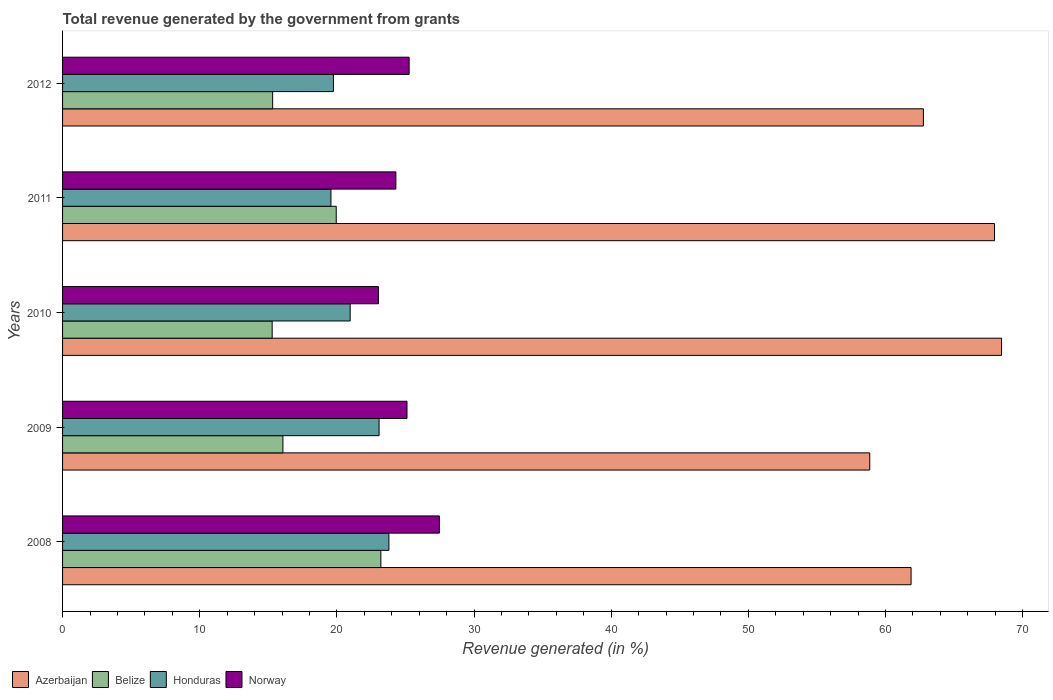What is the label of the 5th group of bars from the top?
Give a very brief answer. 2008. In how many cases, is the number of bars for a given year not equal to the number of legend labels?
Offer a very short reply. 0. What is the total revenue generated in Norway in 2011?
Give a very brief answer. 24.3. Across all years, what is the maximum total revenue generated in Honduras?
Make the answer very short. 23.79. Across all years, what is the minimum total revenue generated in Belize?
Your answer should be very brief. 15.28. In which year was the total revenue generated in Azerbaijan maximum?
Your answer should be compact. 2010. In which year was the total revenue generated in Norway minimum?
Provide a succinct answer. 2010. What is the total total revenue generated in Honduras in the graph?
Provide a succinct answer. 107.16. What is the difference between the total revenue generated in Norway in 2008 and that in 2012?
Offer a very short reply. 2.2. What is the difference between the total revenue generated in Honduras in 2011 and the total revenue generated in Belize in 2008?
Offer a terse response. -3.64. What is the average total revenue generated in Azerbaijan per year?
Your answer should be compact. 63.98. In the year 2012, what is the difference between the total revenue generated in Azerbaijan and total revenue generated in Honduras?
Provide a short and direct response. 43.01. In how many years, is the total revenue generated in Norway greater than 6 %?
Your response must be concise. 5. What is the ratio of the total revenue generated in Azerbaijan in 2008 to that in 2009?
Provide a short and direct response. 1.05. Is the total revenue generated in Azerbaijan in 2008 less than that in 2012?
Provide a short and direct response. Yes. Is the difference between the total revenue generated in Azerbaijan in 2009 and 2012 greater than the difference between the total revenue generated in Honduras in 2009 and 2012?
Your answer should be compact. No. What is the difference between the highest and the second highest total revenue generated in Belize?
Give a very brief answer. 3.25. What is the difference between the highest and the lowest total revenue generated in Belize?
Provide a succinct answer. 7.93. Is it the case that in every year, the sum of the total revenue generated in Belize and total revenue generated in Honduras is greater than the sum of total revenue generated in Norway and total revenue generated in Azerbaijan?
Your answer should be compact. No. What does the 1st bar from the bottom in 2011 represents?
Offer a terse response. Azerbaijan. Is it the case that in every year, the sum of the total revenue generated in Norway and total revenue generated in Belize is greater than the total revenue generated in Honduras?
Offer a terse response. Yes. How many years are there in the graph?
Provide a succinct answer. 5. Does the graph contain any zero values?
Your answer should be very brief. No. Does the graph contain grids?
Your response must be concise. No. Where does the legend appear in the graph?
Provide a succinct answer. Bottom left. How many legend labels are there?
Give a very brief answer. 4. How are the legend labels stacked?
Keep it short and to the point. Horizontal. What is the title of the graph?
Offer a terse response. Total revenue generated by the government from grants. Does "Isle of Man" appear as one of the legend labels in the graph?
Make the answer very short. No. What is the label or title of the X-axis?
Offer a terse response. Revenue generated (in %). What is the Revenue generated (in %) in Azerbaijan in 2008?
Your answer should be compact. 61.87. What is the Revenue generated (in %) of Belize in 2008?
Provide a short and direct response. 23.21. What is the Revenue generated (in %) in Honduras in 2008?
Your answer should be very brief. 23.79. What is the Revenue generated (in %) in Norway in 2008?
Your response must be concise. 27.47. What is the Revenue generated (in %) of Azerbaijan in 2009?
Your answer should be compact. 58.85. What is the Revenue generated (in %) of Belize in 2009?
Make the answer very short. 16.07. What is the Revenue generated (in %) of Honduras in 2009?
Your answer should be compact. 23.08. What is the Revenue generated (in %) in Norway in 2009?
Make the answer very short. 25.11. What is the Revenue generated (in %) of Azerbaijan in 2010?
Provide a short and direct response. 68.46. What is the Revenue generated (in %) in Belize in 2010?
Your answer should be compact. 15.28. What is the Revenue generated (in %) in Honduras in 2010?
Your answer should be very brief. 20.97. What is the Revenue generated (in %) in Norway in 2010?
Provide a short and direct response. 23.03. What is the Revenue generated (in %) of Azerbaijan in 2011?
Make the answer very short. 67.95. What is the Revenue generated (in %) in Belize in 2011?
Make the answer very short. 19.95. What is the Revenue generated (in %) of Honduras in 2011?
Provide a short and direct response. 19.57. What is the Revenue generated (in %) in Norway in 2011?
Offer a very short reply. 24.3. What is the Revenue generated (in %) of Azerbaijan in 2012?
Offer a very short reply. 62.76. What is the Revenue generated (in %) in Belize in 2012?
Your answer should be compact. 15.32. What is the Revenue generated (in %) in Honduras in 2012?
Make the answer very short. 19.75. What is the Revenue generated (in %) in Norway in 2012?
Your answer should be very brief. 25.27. Across all years, what is the maximum Revenue generated (in %) of Azerbaijan?
Your response must be concise. 68.46. Across all years, what is the maximum Revenue generated (in %) of Belize?
Provide a succinct answer. 23.21. Across all years, what is the maximum Revenue generated (in %) in Honduras?
Make the answer very short. 23.79. Across all years, what is the maximum Revenue generated (in %) of Norway?
Provide a short and direct response. 27.47. Across all years, what is the minimum Revenue generated (in %) of Azerbaijan?
Ensure brevity in your answer.  58.85. Across all years, what is the minimum Revenue generated (in %) of Belize?
Provide a short and direct response. 15.28. Across all years, what is the minimum Revenue generated (in %) of Honduras?
Your answer should be very brief. 19.57. Across all years, what is the minimum Revenue generated (in %) of Norway?
Your answer should be compact. 23.03. What is the total Revenue generated (in %) in Azerbaijan in the graph?
Your answer should be very brief. 319.89. What is the total Revenue generated (in %) in Belize in the graph?
Provide a short and direct response. 89.83. What is the total Revenue generated (in %) in Honduras in the graph?
Provide a succinct answer. 107.16. What is the total Revenue generated (in %) of Norway in the graph?
Give a very brief answer. 125.19. What is the difference between the Revenue generated (in %) of Azerbaijan in 2008 and that in 2009?
Ensure brevity in your answer.  3.01. What is the difference between the Revenue generated (in %) of Belize in 2008 and that in 2009?
Your answer should be compact. 7.14. What is the difference between the Revenue generated (in %) in Honduras in 2008 and that in 2009?
Give a very brief answer. 0.72. What is the difference between the Revenue generated (in %) of Norway in 2008 and that in 2009?
Offer a very short reply. 2.36. What is the difference between the Revenue generated (in %) of Azerbaijan in 2008 and that in 2010?
Your response must be concise. -6.6. What is the difference between the Revenue generated (in %) in Belize in 2008 and that in 2010?
Ensure brevity in your answer.  7.93. What is the difference between the Revenue generated (in %) in Honduras in 2008 and that in 2010?
Give a very brief answer. 2.82. What is the difference between the Revenue generated (in %) in Norway in 2008 and that in 2010?
Offer a very short reply. 4.44. What is the difference between the Revenue generated (in %) in Azerbaijan in 2008 and that in 2011?
Provide a succinct answer. -6.09. What is the difference between the Revenue generated (in %) in Belize in 2008 and that in 2011?
Make the answer very short. 3.25. What is the difference between the Revenue generated (in %) in Honduras in 2008 and that in 2011?
Provide a succinct answer. 4.23. What is the difference between the Revenue generated (in %) in Norway in 2008 and that in 2011?
Offer a very short reply. 3.17. What is the difference between the Revenue generated (in %) in Azerbaijan in 2008 and that in 2012?
Keep it short and to the point. -0.9. What is the difference between the Revenue generated (in %) in Belize in 2008 and that in 2012?
Keep it short and to the point. 7.89. What is the difference between the Revenue generated (in %) of Honduras in 2008 and that in 2012?
Offer a very short reply. 4.04. What is the difference between the Revenue generated (in %) in Norway in 2008 and that in 2012?
Give a very brief answer. 2.2. What is the difference between the Revenue generated (in %) in Azerbaijan in 2009 and that in 2010?
Your answer should be very brief. -9.61. What is the difference between the Revenue generated (in %) of Belize in 2009 and that in 2010?
Your response must be concise. 0.78. What is the difference between the Revenue generated (in %) in Honduras in 2009 and that in 2010?
Keep it short and to the point. 2.11. What is the difference between the Revenue generated (in %) of Norway in 2009 and that in 2010?
Make the answer very short. 2.08. What is the difference between the Revenue generated (in %) of Azerbaijan in 2009 and that in 2011?
Your answer should be very brief. -9.1. What is the difference between the Revenue generated (in %) in Belize in 2009 and that in 2011?
Ensure brevity in your answer.  -3.89. What is the difference between the Revenue generated (in %) of Honduras in 2009 and that in 2011?
Your answer should be compact. 3.51. What is the difference between the Revenue generated (in %) in Norway in 2009 and that in 2011?
Your answer should be compact. 0.81. What is the difference between the Revenue generated (in %) of Azerbaijan in 2009 and that in 2012?
Make the answer very short. -3.91. What is the difference between the Revenue generated (in %) of Belize in 2009 and that in 2012?
Give a very brief answer. 0.75. What is the difference between the Revenue generated (in %) of Honduras in 2009 and that in 2012?
Your answer should be very brief. 3.33. What is the difference between the Revenue generated (in %) in Norway in 2009 and that in 2012?
Make the answer very short. -0.16. What is the difference between the Revenue generated (in %) of Azerbaijan in 2010 and that in 2011?
Provide a succinct answer. 0.51. What is the difference between the Revenue generated (in %) of Belize in 2010 and that in 2011?
Offer a very short reply. -4.67. What is the difference between the Revenue generated (in %) of Honduras in 2010 and that in 2011?
Offer a terse response. 1.4. What is the difference between the Revenue generated (in %) in Norway in 2010 and that in 2011?
Give a very brief answer. -1.27. What is the difference between the Revenue generated (in %) in Azerbaijan in 2010 and that in 2012?
Your response must be concise. 5.7. What is the difference between the Revenue generated (in %) in Belize in 2010 and that in 2012?
Offer a terse response. -0.03. What is the difference between the Revenue generated (in %) in Honduras in 2010 and that in 2012?
Your response must be concise. 1.22. What is the difference between the Revenue generated (in %) in Norway in 2010 and that in 2012?
Provide a short and direct response. -2.24. What is the difference between the Revenue generated (in %) of Azerbaijan in 2011 and that in 2012?
Give a very brief answer. 5.19. What is the difference between the Revenue generated (in %) in Belize in 2011 and that in 2012?
Ensure brevity in your answer.  4.64. What is the difference between the Revenue generated (in %) in Honduras in 2011 and that in 2012?
Keep it short and to the point. -0.18. What is the difference between the Revenue generated (in %) in Norway in 2011 and that in 2012?
Provide a succinct answer. -0.97. What is the difference between the Revenue generated (in %) in Azerbaijan in 2008 and the Revenue generated (in %) in Belize in 2009?
Provide a succinct answer. 45.8. What is the difference between the Revenue generated (in %) of Azerbaijan in 2008 and the Revenue generated (in %) of Honduras in 2009?
Keep it short and to the point. 38.79. What is the difference between the Revenue generated (in %) in Azerbaijan in 2008 and the Revenue generated (in %) in Norway in 2009?
Your answer should be compact. 36.75. What is the difference between the Revenue generated (in %) of Belize in 2008 and the Revenue generated (in %) of Honduras in 2009?
Give a very brief answer. 0.13. What is the difference between the Revenue generated (in %) of Belize in 2008 and the Revenue generated (in %) of Norway in 2009?
Your response must be concise. -1.91. What is the difference between the Revenue generated (in %) of Honduras in 2008 and the Revenue generated (in %) of Norway in 2009?
Your answer should be compact. -1.32. What is the difference between the Revenue generated (in %) of Azerbaijan in 2008 and the Revenue generated (in %) of Belize in 2010?
Ensure brevity in your answer.  46.58. What is the difference between the Revenue generated (in %) in Azerbaijan in 2008 and the Revenue generated (in %) in Honduras in 2010?
Provide a succinct answer. 40.9. What is the difference between the Revenue generated (in %) of Azerbaijan in 2008 and the Revenue generated (in %) of Norway in 2010?
Your answer should be very brief. 38.84. What is the difference between the Revenue generated (in %) in Belize in 2008 and the Revenue generated (in %) in Honduras in 2010?
Make the answer very short. 2.24. What is the difference between the Revenue generated (in %) in Belize in 2008 and the Revenue generated (in %) in Norway in 2010?
Give a very brief answer. 0.18. What is the difference between the Revenue generated (in %) in Honduras in 2008 and the Revenue generated (in %) in Norway in 2010?
Your response must be concise. 0.76. What is the difference between the Revenue generated (in %) in Azerbaijan in 2008 and the Revenue generated (in %) in Belize in 2011?
Offer a very short reply. 41.91. What is the difference between the Revenue generated (in %) of Azerbaijan in 2008 and the Revenue generated (in %) of Honduras in 2011?
Your response must be concise. 42.3. What is the difference between the Revenue generated (in %) of Azerbaijan in 2008 and the Revenue generated (in %) of Norway in 2011?
Provide a short and direct response. 37.56. What is the difference between the Revenue generated (in %) of Belize in 2008 and the Revenue generated (in %) of Honduras in 2011?
Your response must be concise. 3.64. What is the difference between the Revenue generated (in %) of Belize in 2008 and the Revenue generated (in %) of Norway in 2011?
Provide a short and direct response. -1.09. What is the difference between the Revenue generated (in %) in Honduras in 2008 and the Revenue generated (in %) in Norway in 2011?
Make the answer very short. -0.51. What is the difference between the Revenue generated (in %) in Azerbaijan in 2008 and the Revenue generated (in %) in Belize in 2012?
Make the answer very short. 46.55. What is the difference between the Revenue generated (in %) of Azerbaijan in 2008 and the Revenue generated (in %) of Honduras in 2012?
Offer a terse response. 42.12. What is the difference between the Revenue generated (in %) in Azerbaijan in 2008 and the Revenue generated (in %) in Norway in 2012?
Your response must be concise. 36.6. What is the difference between the Revenue generated (in %) in Belize in 2008 and the Revenue generated (in %) in Honduras in 2012?
Provide a succinct answer. 3.46. What is the difference between the Revenue generated (in %) of Belize in 2008 and the Revenue generated (in %) of Norway in 2012?
Give a very brief answer. -2.06. What is the difference between the Revenue generated (in %) of Honduras in 2008 and the Revenue generated (in %) of Norway in 2012?
Offer a terse response. -1.48. What is the difference between the Revenue generated (in %) of Azerbaijan in 2009 and the Revenue generated (in %) of Belize in 2010?
Provide a succinct answer. 43.57. What is the difference between the Revenue generated (in %) of Azerbaijan in 2009 and the Revenue generated (in %) of Honduras in 2010?
Provide a succinct answer. 37.88. What is the difference between the Revenue generated (in %) of Azerbaijan in 2009 and the Revenue generated (in %) of Norway in 2010?
Make the answer very short. 35.82. What is the difference between the Revenue generated (in %) of Belize in 2009 and the Revenue generated (in %) of Honduras in 2010?
Keep it short and to the point. -4.9. What is the difference between the Revenue generated (in %) of Belize in 2009 and the Revenue generated (in %) of Norway in 2010?
Your answer should be compact. -6.96. What is the difference between the Revenue generated (in %) of Honduras in 2009 and the Revenue generated (in %) of Norway in 2010?
Make the answer very short. 0.05. What is the difference between the Revenue generated (in %) of Azerbaijan in 2009 and the Revenue generated (in %) of Belize in 2011?
Offer a terse response. 38.9. What is the difference between the Revenue generated (in %) in Azerbaijan in 2009 and the Revenue generated (in %) in Honduras in 2011?
Offer a very short reply. 39.28. What is the difference between the Revenue generated (in %) of Azerbaijan in 2009 and the Revenue generated (in %) of Norway in 2011?
Keep it short and to the point. 34.55. What is the difference between the Revenue generated (in %) in Belize in 2009 and the Revenue generated (in %) in Honduras in 2011?
Your answer should be very brief. -3.5. What is the difference between the Revenue generated (in %) in Belize in 2009 and the Revenue generated (in %) in Norway in 2011?
Provide a succinct answer. -8.24. What is the difference between the Revenue generated (in %) of Honduras in 2009 and the Revenue generated (in %) of Norway in 2011?
Provide a short and direct response. -1.22. What is the difference between the Revenue generated (in %) in Azerbaijan in 2009 and the Revenue generated (in %) in Belize in 2012?
Offer a very short reply. 43.54. What is the difference between the Revenue generated (in %) of Azerbaijan in 2009 and the Revenue generated (in %) of Honduras in 2012?
Provide a short and direct response. 39.1. What is the difference between the Revenue generated (in %) in Azerbaijan in 2009 and the Revenue generated (in %) in Norway in 2012?
Provide a short and direct response. 33.58. What is the difference between the Revenue generated (in %) of Belize in 2009 and the Revenue generated (in %) of Honduras in 2012?
Ensure brevity in your answer.  -3.68. What is the difference between the Revenue generated (in %) of Belize in 2009 and the Revenue generated (in %) of Norway in 2012?
Your answer should be very brief. -9.2. What is the difference between the Revenue generated (in %) in Honduras in 2009 and the Revenue generated (in %) in Norway in 2012?
Offer a very short reply. -2.19. What is the difference between the Revenue generated (in %) of Azerbaijan in 2010 and the Revenue generated (in %) of Belize in 2011?
Your answer should be very brief. 48.51. What is the difference between the Revenue generated (in %) in Azerbaijan in 2010 and the Revenue generated (in %) in Honduras in 2011?
Your answer should be compact. 48.89. What is the difference between the Revenue generated (in %) of Azerbaijan in 2010 and the Revenue generated (in %) of Norway in 2011?
Provide a short and direct response. 44.16. What is the difference between the Revenue generated (in %) in Belize in 2010 and the Revenue generated (in %) in Honduras in 2011?
Your answer should be compact. -4.28. What is the difference between the Revenue generated (in %) of Belize in 2010 and the Revenue generated (in %) of Norway in 2011?
Offer a very short reply. -9.02. What is the difference between the Revenue generated (in %) in Honduras in 2010 and the Revenue generated (in %) in Norway in 2011?
Ensure brevity in your answer.  -3.33. What is the difference between the Revenue generated (in %) of Azerbaijan in 2010 and the Revenue generated (in %) of Belize in 2012?
Ensure brevity in your answer.  53.14. What is the difference between the Revenue generated (in %) of Azerbaijan in 2010 and the Revenue generated (in %) of Honduras in 2012?
Keep it short and to the point. 48.71. What is the difference between the Revenue generated (in %) of Azerbaijan in 2010 and the Revenue generated (in %) of Norway in 2012?
Give a very brief answer. 43.19. What is the difference between the Revenue generated (in %) in Belize in 2010 and the Revenue generated (in %) in Honduras in 2012?
Your answer should be very brief. -4.47. What is the difference between the Revenue generated (in %) in Belize in 2010 and the Revenue generated (in %) in Norway in 2012?
Make the answer very short. -9.99. What is the difference between the Revenue generated (in %) of Honduras in 2010 and the Revenue generated (in %) of Norway in 2012?
Your answer should be compact. -4.3. What is the difference between the Revenue generated (in %) of Azerbaijan in 2011 and the Revenue generated (in %) of Belize in 2012?
Offer a very short reply. 52.63. What is the difference between the Revenue generated (in %) of Azerbaijan in 2011 and the Revenue generated (in %) of Honduras in 2012?
Offer a terse response. 48.2. What is the difference between the Revenue generated (in %) in Azerbaijan in 2011 and the Revenue generated (in %) in Norway in 2012?
Offer a terse response. 42.68. What is the difference between the Revenue generated (in %) in Belize in 2011 and the Revenue generated (in %) in Honduras in 2012?
Offer a very short reply. 0.2. What is the difference between the Revenue generated (in %) of Belize in 2011 and the Revenue generated (in %) of Norway in 2012?
Your answer should be very brief. -5.32. What is the difference between the Revenue generated (in %) of Honduras in 2011 and the Revenue generated (in %) of Norway in 2012?
Ensure brevity in your answer.  -5.7. What is the average Revenue generated (in %) of Azerbaijan per year?
Offer a very short reply. 63.98. What is the average Revenue generated (in %) in Belize per year?
Offer a very short reply. 17.97. What is the average Revenue generated (in %) in Honduras per year?
Keep it short and to the point. 21.43. What is the average Revenue generated (in %) of Norway per year?
Provide a short and direct response. 25.04. In the year 2008, what is the difference between the Revenue generated (in %) of Azerbaijan and Revenue generated (in %) of Belize?
Offer a terse response. 38.66. In the year 2008, what is the difference between the Revenue generated (in %) in Azerbaijan and Revenue generated (in %) in Honduras?
Make the answer very short. 38.07. In the year 2008, what is the difference between the Revenue generated (in %) in Azerbaijan and Revenue generated (in %) in Norway?
Provide a short and direct response. 34.39. In the year 2008, what is the difference between the Revenue generated (in %) of Belize and Revenue generated (in %) of Honduras?
Your answer should be compact. -0.59. In the year 2008, what is the difference between the Revenue generated (in %) of Belize and Revenue generated (in %) of Norway?
Keep it short and to the point. -4.26. In the year 2008, what is the difference between the Revenue generated (in %) of Honduras and Revenue generated (in %) of Norway?
Make the answer very short. -3.68. In the year 2009, what is the difference between the Revenue generated (in %) of Azerbaijan and Revenue generated (in %) of Belize?
Your answer should be compact. 42.79. In the year 2009, what is the difference between the Revenue generated (in %) in Azerbaijan and Revenue generated (in %) in Honduras?
Provide a succinct answer. 35.77. In the year 2009, what is the difference between the Revenue generated (in %) of Azerbaijan and Revenue generated (in %) of Norway?
Give a very brief answer. 33.74. In the year 2009, what is the difference between the Revenue generated (in %) of Belize and Revenue generated (in %) of Honduras?
Provide a succinct answer. -7.01. In the year 2009, what is the difference between the Revenue generated (in %) in Belize and Revenue generated (in %) in Norway?
Your answer should be very brief. -9.05. In the year 2009, what is the difference between the Revenue generated (in %) of Honduras and Revenue generated (in %) of Norway?
Offer a terse response. -2.04. In the year 2010, what is the difference between the Revenue generated (in %) in Azerbaijan and Revenue generated (in %) in Belize?
Offer a very short reply. 53.18. In the year 2010, what is the difference between the Revenue generated (in %) of Azerbaijan and Revenue generated (in %) of Honduras?
Give a very brief answer. 47.49. In the year 2010, what is the difference between the Revenue generated (in %) of Azerbaijan and Revenue generated (in %) of Norway?
Your answer should be very brief. 45.43. In the year 2010, what is the difference between the Revenue generated (in %) in Belize and Revenue generated (in %) in Honduras?
Offer a very short reply. -5.69. In the year 2010, what is the difference between the Revenue generated (in %) of Belize and Revenue generated (in %) of Norway?
Your answer should be compact. -7.75. In the year 2010, what is the difference between the Revenue generated (in %) of Honduras and Revenue generated (in %) of Norway?
Ensure brevity in your answer.  -2.06. In the year 2011, what is the difference between the Revenue generated (in %) of Azerbaijan and Revenue generated (in %) of Belize?
Provide a short and direct response. 48. In the year 2011, what is the difference between the Revenue generated (in %) in Azerbaijan and Revenue generated (in %) in Honduras?
Offer a very short reply. 48.38. In the year 2011, what is the difference between the Revenue generated (in %) in Azerbaijan and Revenue generated (in %) in Norway?
Offer a very short reply. 43.65. In the year 2011, what is the difference between the Revenue generated (in %) of Belize and Revenue generated (in %) of Honduras?
Your response must be concise. 0.39. In the year 2011, what is the difference between the Revenue generated (in %) in Belize and Revenue generated (in %) in Norway?
Your response must be concise. -4.35. In the year 2011, what is the difference between the Revenue generated (in %) of Honduras and Revenue generated (in %) of Norway?
Give a very brief answer. -4.74. In the year 2012, what is the difference between the Revenue generated (in %) in Azerbaijan and Revenue generated (in %) in Belize?
Your response must be concise. 47.45. In the year 2012, what is the difference between the Revenue generated (in %) of Azerbaijan and Revenue generated (in %) of Honduras?
Ensure brevity in your answer.  43.01. In the year 2012, what is the difference between the Revenue generated (in %) in Azerbaijan and Revenue generated (in %) in Norway?
Provide a short and direct response. 37.49. In the year 2012, what is the difference between the Revenue generated (in %) in Belize and Revenue generated (in %) in Honduras?
Make the answer very short. -4.43. In the year 2012, what is the difference between the Revenue generated (in %) of Belize and Revenue generated (in %) of Norway?
Your response must be concise. -9.95. In the year 2012, what is the difference between the Revenue generated (in %) in Honduras and Revenue generated (in %) in Norway?
Provide a short and direct response. -5.52. What is the ratio of the Revenue generated (in %) of Azerbaijan in 2008 to that in 2009?
Provide a succinct answer. 1.05. What is the ratio of the Revenue generated (in %) of Belize in 2008 to that in 2009?
Provide a short and direct response. 1.44. What is the ratio of the Revenue generated (in %) of Honduras in 2008 to that in 2009?
Ensure brevity in your answer.  1.03. What is the ratio of the Revenue generated (in %) in Norway in 2008 to that in 2009?
Your response must be concise. 1.09. What is the ratio of the Revenue generated (in %) in Azerbaijan in 2008 to that in 2010?
Your answer should be compact. 0.9. What is the ratio of the Revenue generated (in %) in Belize in 2008 to that in 2010?
Provide a succinct answer. 1.52. What is the ratio of the Revenue generated (in %) of Honduras in 2008 to that in 2010?
Your answer should be compact. 1.13. What is the ratio of the Revenue generated (in %) in Norway in 2008 to that in 2010?
Offer a terse response. 1.19. What is the ratio of the Revenue generated (in %) of Azerbaijan in 2008 to that in 2011?
Ensure brevity in your answer.  0.91. What is the ratio of the Revenue generated (in %) of Belize in 2008 to that in 2011?
Make the answer very short. 1.16. What is the ratio of the Revenue generated (in %) in Honduras in 2008 to that in 2011?
Keep it short and to the point. 1.22. What is the ratio of the Revenue generated (in %) of Norway in 2008 to that in 2011?
Provide a succinct answer. 1.13. What is the ratio of the Revenue generated (in %) in Azerbaijan in 2008 to that in 2012?
Give a very brief answer. 0.99. What is the ratio of the Revenue generated (in %) of Belize in 2008 to that in 2012?
Give a very brief answer. 1.52. What is the ratio of the Revenue generated (in %) of Honduras in 2008 to that in 2012?
Your response must be concise. 1.2. What is the ratio of the Revenue generated (in %) in Norway in 2008 to that in 2012?
Provide a succinct answer. 1.09. What is the ratio of the Revenue generated (in %) of Azerbaijan in 2009 to that in 2010?
Your response must be concise. 0.86. What is the ratio of the Revenue generated (in %) of Belize in 2009 to that in 2010?
Give a very brief answer. 1.05. What is the ratio of the Revenue generated (in %) of Honduras in 2009 to that in 2010?
Ensure brevity in your answer.  1.1. What is the ratio of the Revenue generated (in %) in Norway in 2009 to that in 2010?
Offer a very short reply. 1.09. What is the ratio of the Revenue generated (in %) of Azerbaijan in 2009 to that in 2011?
Your answer should be very brief. 0.87. What is the ratio of the Revenue generated (in %) in Belize in 2009 to that in 2011?
Your answer should be compact. 0.81. What is the ratio of the Revenue generated (in %) of Honduras in 2009 to that in 2011?
Make the answer very short. 1.18. What is the ratio of the Revenue generated (in %) of Norway in 2009 to that in 2011?
Make the answer very short. 1.03. What is the ratio of the Revenue generated (in %) in Azerbaijan in 2009 to that in 2012?
Your answer should be very brief. 0.94. What is the ratio of the Revenue generated (in %) of Belize in 2009 to that in 2012?
Your answer should be very brief. 1.05. What is the ratio of the Revenue generated (in %) of Honduras in 2009 to that in 2012?
Ensure brevity in your answer.  1.17. What is the ratio of the Revenue generated (in %) in Norway in 2009 to that in 2012?
Keep it short and to the point. 0.99. What is the ratio of the Revenue generated (in %) in Azerbaijan in 2010 to that in 2011?
Ensure brevity in your answer.  1.01. What is the ratio of the Revenue generated (in %) of Belize in 2010 to that in 2011?
Give a very brief answer. 0.77. What is the ratio of the Revenue generated (in %) of Honduras in 2010 to that in 2011?
Provide a succinct answer. 1.07. What is the ratio of the Revenue generated (in %) of Norway in 2010 to that in 2011?
Provide a succinct answer. 0.95. What is the ratio of the Revenue generated (in %) in Azerbaijan in 2010 to that in 2012?
Provide a succinct answer. 1.09. What is the ratio of the Revenue generated (in %) in Honduras in 2010 to that in 2012?
Your response must be concise. 1.06. What is the ratio of the Revenue generated (in %) of Norway in 2010 to that in 2012?
Your answer should be very brief. 0.91. What is the ratio of the Revenue generated (in %) in Azerbaijan in 2011 to that in 2012?
Your response must be concise. 1.08. What is the ratio of the Revenue generated (in %) in Belize in 2011 to that in 2012?
Give a very brief answer. 1.3. What is the ratio of the Revenue generated (in %) in Honduras in 2011 to that in 2012?
Keep it short and to the point. 0.99. What is the ratio of the Revenue generated (in %) of Norway in 2011 to that in 2012?
Provide a short and direct response. 0.96. What is the difference between the highest and the second highest Revenue generated (in %) in Azerbaijan?
Provide a succinct answer. 0.51. What is the difference between the highest and the second highest Revenue generated (in %) of Belize?
Offer a very short reply. 3.25. What is the difference between the highest and the second highest Revenue generated (in %) in Honduras?
Keep it short and to the point. 0.72. What is the difference between the highest and the second highest Revenue generated (in %) of Norway?
Keep it short and to the point. 2.2. What is the difference between the highest and the lowest Revenue generated (in %) in Azerbaijan?
Your response must be concise. 9.61. What is the difference between the highest and the lowest Revenue generated (in %) in Belize?
Provide a short and direct response. 7.93. What is the difference between the highest and the lowest Revenue generated (in %) of Honduras?
Your answer should be compact. 4.23. What is the difference between the highest and the lowest Revenue generated (in %) of Norway?
Your answer should be very brief. 4.44. 